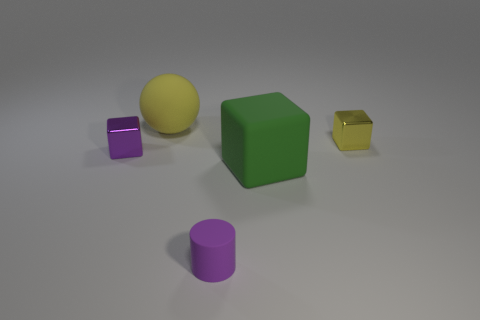Subtract all tiny metal blocks. How many blocks are left? 1 Subtract all cylinders. How many objects are left? 4 Add 3 large yellow shiny cylinders. How many objects exist? 8 Subtract all green cubes. How many cubes are left? 2 Subtract 3 blocks. How many blocks are left? 0 Subtract 0 blue cylinders. How many objects are left? 5 Subtract all cyan cubes. Subtract all red cylinders. How many cubes are left? 3 Subtract all purple cylinders. How many green cubes are left? 1 Subtract all small red things. Subtract all tiny purple cubes. How many objects are left? 4 Add 3 green objects. How many green objects are left? 4 